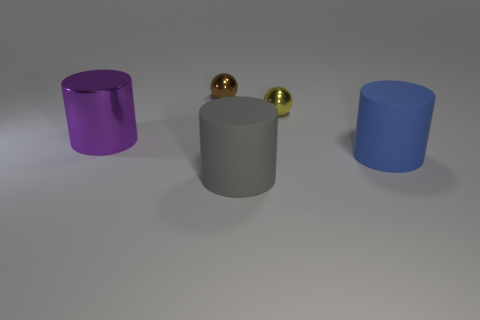Subtract all metallic cylinders. How many cylinders are left? 2 Add 5 large objects. How many objects exist? 10 Subtract all yellow balls. How many balls are left? 1 Subtract 2 cylinders. How many cylinders are left? 1 Subtract all cylinders. How many objects are left? 2 Subtract all cyan spheres. Subtract all purple cubes. How many spheres are left? 2 Subtract all cyan balls. How many gray cylinders are left? 1 Subtract all large purple metal balls. Subtract all big rubber objects. How many objects are left? 3 Add 5 large purple metallic objects. How many large purple metallic objects are left? 6 Add 2 tiny brown shiny things. How many tiny brown shiny things exist? 3 